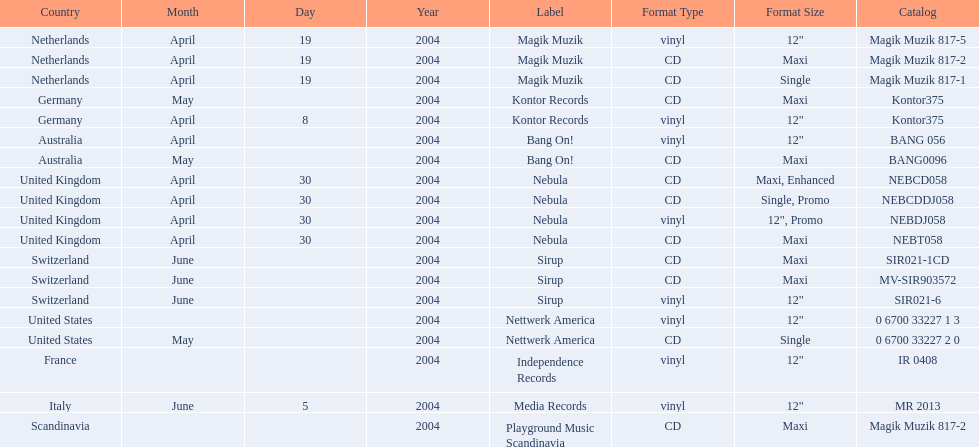What region was in the sir021-1cd catalog? Switzerland. 